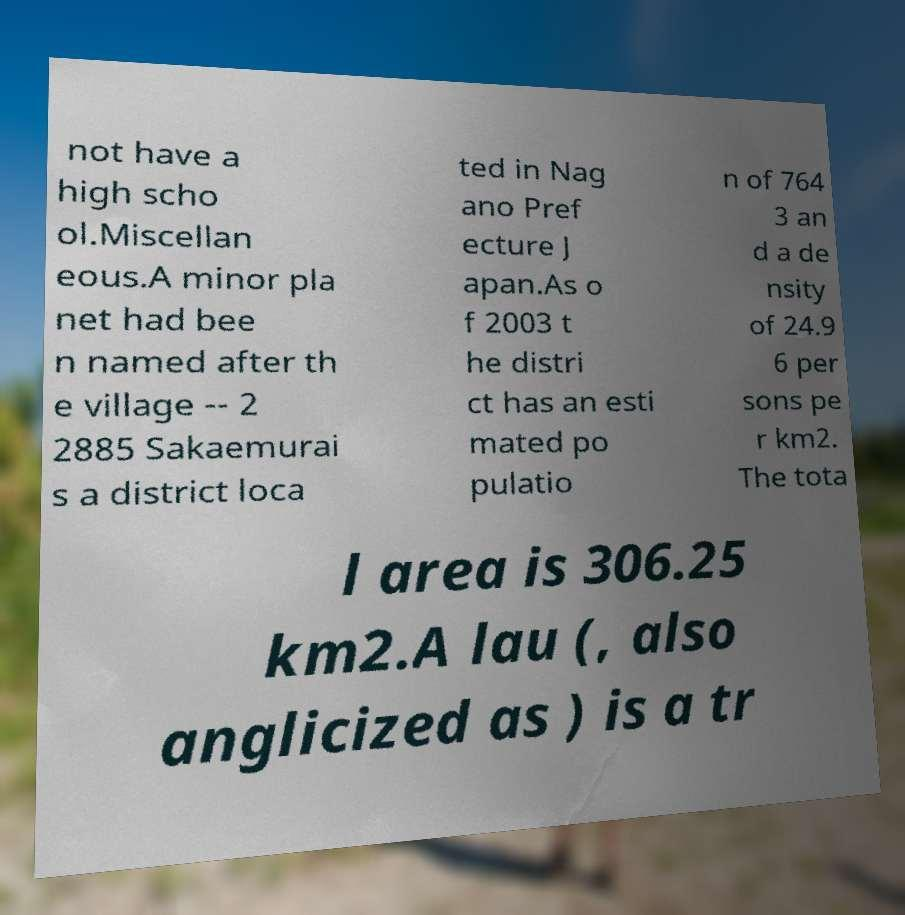For documentation purposes, I need the text within this image transcribed. Could you provide that? not have a high scho ol.Miscellan eous.A minor pla net had bee n named after th e village -- 2 2885 Sakaemurai s a district loca ted in Nag ano Pref ecture J apan.As o f 2003 t he distri ct has an esti mated po pulatio n of 764 3 an d a de nsity of 24.9 6 per sons pe r km2. The tota l area is 306.25 km2.A lau (, also anglicized as ) is a tr 